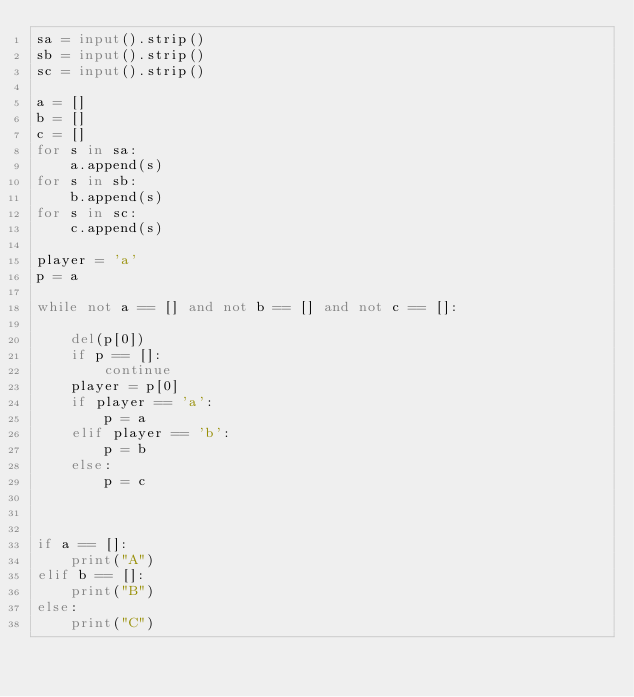<code> <loc_0><loc_0><loc_500><loc_500><_Python_>sa = input().strip()
sb = input().strip()
sc = input().strip()

a = []
b = []
c = []
for s in sa:
    a.append(s)
for s in sb:
    b.append(s)
for s in sc:
    c.append(s)

player = 'a'
p = a

while not a == [] and not b == [] and not c == []:

    del(p[0])
    if p == []:
        continue
    player = p[0]
    if player == 'a':
        p = a
    elif player == 'b':
        p = b
    else:
        p = c

        

if a == []:
    print("A")
elif b == []:
    print("B")
else:
    print("C")</code> 